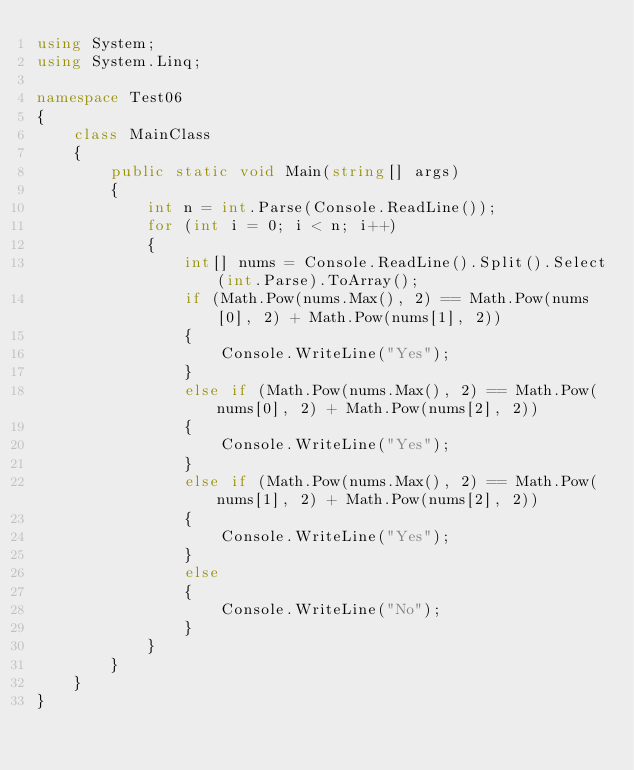<code> <loc_0><loc_0><loc_500><loc_500><_C#_>using System;
using System.Linq;

namespace Test06
{
	class MainClass
	{
		public static void Main(string[] args)
		{
			int n = int.Parse(Console.ReadLine());
			for (int i = 0; i < n; i++)
			{
				int[] nums = Console.ReadLine().Split().Select(int.Parse).ToArray();
				if (Math.Pow(nums.Max(), 2) == Math.Pow(nums[0], 2) + Math.Pow(nums[1], 2))
				{
					Console.WriteLine("Yes");
				}
				else if (Math.Pow(nums.Max(), 2) == Math.Pow(nums[0], 2) + Math.Pow(nums[2], 2))
				{
					Console.WriteLine("Yes");
				}
				else if (Math.Pow(nums.Max(), 2) == Math.Pow(nums[1], 2) + Math.Pow(nums[2], 2))
				{
					Console.WriteLine("Yes");
				}
				else
				{
					Console.WriteLine("No");
				}
			}
		}
	}
}</code> 